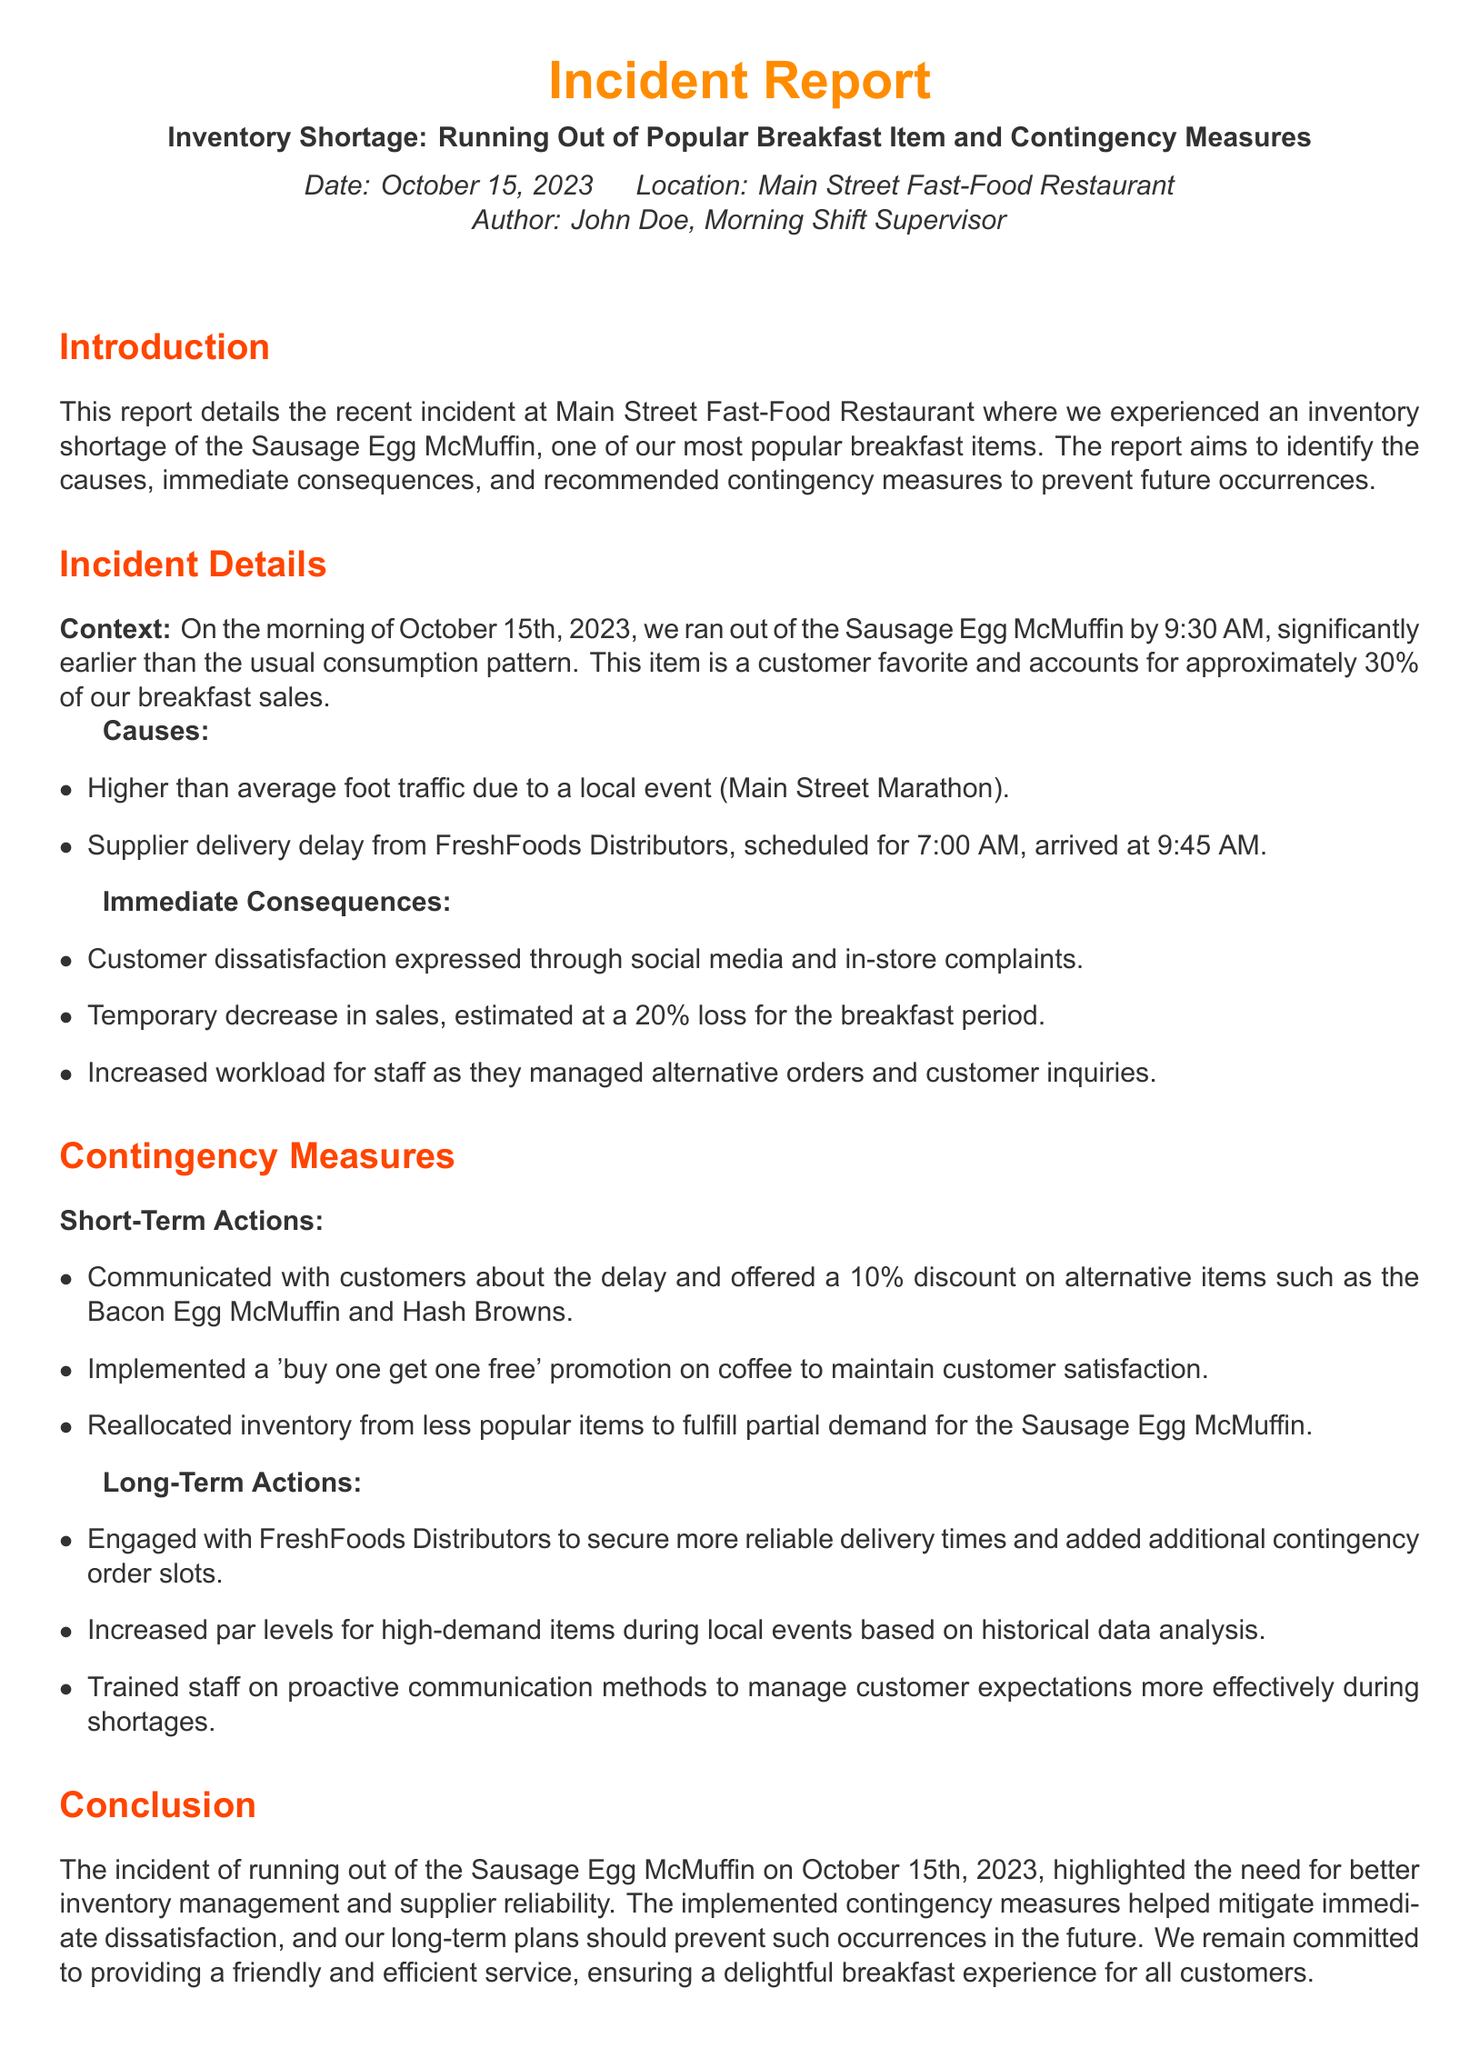what was the date of the incident? The date of the incident is specified in the document as October 15, 2023.
Answer: October 15, 2023 who authored the incident report? The author of the incident report is mentioned as John Doe, the Morning Shift Supervisor.
Answer: John Doe what item ran out of stock? The document states that the item that ran out of stock is the Sausage Egg McMuffin.
Answer: Sausage Egg McMuffin what percent of breakfast sales does the item account for? The report indicates that the Sausage Egg McMuffin accounts for approximately 30 percent of breakfast sales.
Answer: 30 percent what was the estimated loss in sales? The documented estimated loss in sales due to the shortage is a 20 percent decrease for the breakfast period.
Answer: 20 percent what short-term action was taken regarding alternative items? The report mentions that a 10 percent discount was offered on alternative items such as the Bacon Egg McMuffin and Hash Browns.
Answer: 10 percent discount how did the restaurant communicate with customers during the incident? The document states that the restaurant communicated with customers about the delay.
Answer: communicated about the delay who was contacted for reliable delivery times? The report indicates that FreshFoods Distributors was engaged to secure more reliable delivery times.
Answer: FreshFoods Distributors what training was suggested for staff in the long term? The report suggests training staff on proactive communication methods during shortages.
Answer: proactive communication methods 